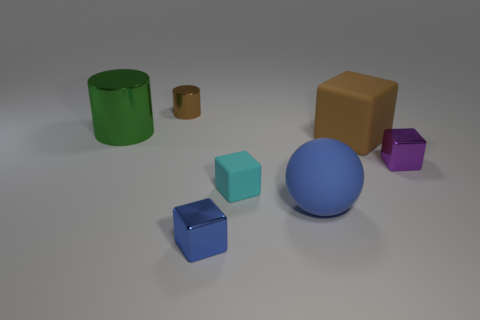There is a brown matte thing that is the same shape as the tiny cyan object; what size is it?
Your answer should be very brief. Large. There is a blue shiny object; is its shape the same as the matte object that is behind the tiny purple cube?
Keep it short and to the point. Yes. What color is the other shiny thing that is the same shape as the green metallic object?
Keep it short and to the point. Brown. Do the metallic object that is right of the rubber sphere and the small matte thing have the same shape?
Ensure brevity in your answer.  Yes. There is a big matte ball; is it the same color as the metallic block in front of the cyan block?
Your response must be concise. Yes. There is another thing that is the same shape as the tiny brown shiny thing; what material is it?
Make the answer very short. Metal. What material is the small cyan thing?
Give a very brief answer. Rubber. The large blue ball that is right of the tiny object on the left side of the tiny metal block left of the purple metal object is made of what material?
Your response must be concise. Rubber. There is a cyan rubber block; is its size the same as the brown thing that is right of the big blue sphere?
Provide a short and direct response. No. What number of things are tiny metallic blocks that are right of the small blue block or tiny shiny blocks in front of the purple shiny object?
Give a very brief answer. 2. 